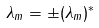Convert formula to latex. <formula><loc_0><loc_0><loc_500><loc_500>\lambda _ { m } = \pm ( \lambda _ { m } ) ^ { * }</formula> 